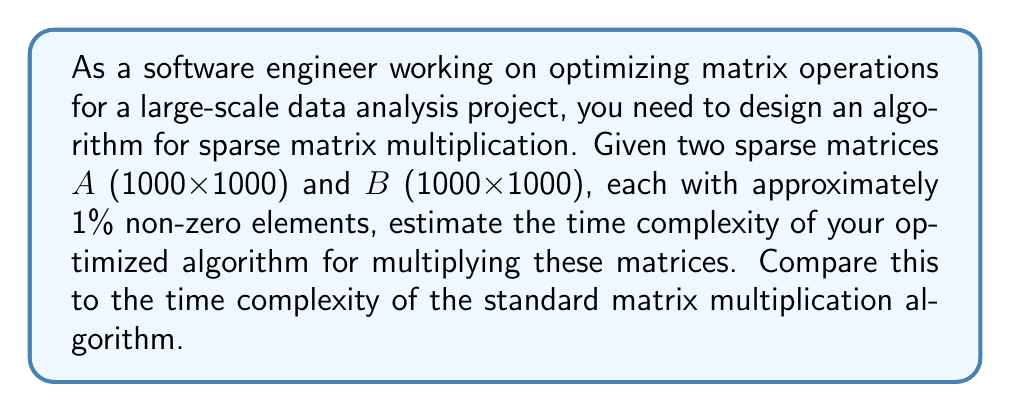Can you answer this question? To design an optimized matrix multiplication algorithm for sparse matrices, we need to consider the following steps:

1. Representation: Use a compressed sparse row (CSR) or compressed sparse column (CSC) format to store the sparse matrices efficiently.

2. Algorithm design:
   a. Iterate only over non-zero elements
   b. Use data structures like hash tables for quick element lookup

3. Time complexity analysis:

Standard matrix multiplication algorithm:
- Time complexity: $O(n^3)$ for $n \times n$ matrices

Optimized sparse matrix multiplication:
- Let $nnz(A)$ and $nnz(B)$ be the number of non-zero elements in $A$ and $B$ respectively
- Time complexity: $O(nnz(A) \cdot n)$ (assuming $B$ is stored in CSC format)

For the given problem:
- $n = 1000$
- $nnz(A) \approx nnz(B) \approx 0.01 \cdot n^2 = 0.01 \cdot 1000^2 = 10,000$

Standard algorithm:
$T_{standard} = O(n^3) = O(1000^3) = O(10^9)$

Optimized algorithm:
$T_{optimized} = O(nnz(A) \cdot n) = O(10,000 \cdot 1000) = O(10^7)$

The optimized algorithm for sparse matrices is approximately 100 times faster than the standard algorithm in this case.
Answer: The time complexity of the optimized sparse matrix multiplication algorithm is $O(nnz(A) \cdot n) = O(10^7)$, which is approximately 100 times faster than the standard matrix multiplication algorithm with time complexity $O(n^3) = O(10^9)$ for the given 1000x1000 matrices with 1% non-zero elements. 